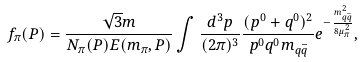<formula> <loc_0><loc_0><loc_500><loc_500>f _ { \pi } ( P ) = \frac { \sqrt { 3 } m } { N _ { \pi } ( P ) E ( m _ { \pi } , { P } ) } \int \frac { d ^ { 3 } { p } } { ( 2 \pi ) ^ { 3 } } \frac { ( p ^ { 0 } + q ^ { 0 } ) ^ { 2 } } { p ^ { 0 } q ^ { 0 } m _ { q \bar { q } } } e ^ { - \frac { m _ { q \bar { q } } ^ { 2 } } { 8 \mu _ { \pi } ^ { 2 } } } ,</formula> 